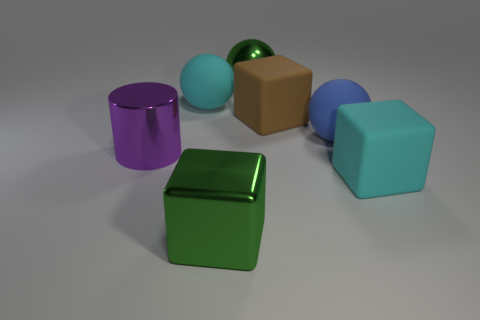Is there anything else that has the same size as the cyan block?
Make the answer very short. Yes. The green object that is behind the big cube left of the large green metallic ball is made of what material?
Give a very brief answer. Metal. Is the shape of the blue matte object the same as the large purple thing?
Offer a very short reply. No. How many cyan matte objects are left of the cyan block and on the right side of the cyan rubber sphere?
Your answer should be compact. 0. Are there an equal number of shiny balls on the left side of the green cube and big brown matte blocks that are behind the blue matte object?
Your answer should be compact. No. Do the cyan matte thing that is to the right of the large blue ball and the rubber cube that is behind the purple thing have the same size?
Your answer should be compact. Yes. What material is the ball that is on the left side of the big blue matte thing and in front of the large green ball?
Your answer should be very brief. Rubber. Is the number of blue cubes less than the number of big blue matte spheres?
Provide a short and direct response. Yes. What is the size of the green thing behind the large cyan matte thing to the left of the large green sphere?
Offer a terse response. Large. What is the shape of the big cyan object that is to the right of the green object on the left side of the metallic sphere that is behind the purple metal cylinder?
Provide a succinct answer. Cube. 